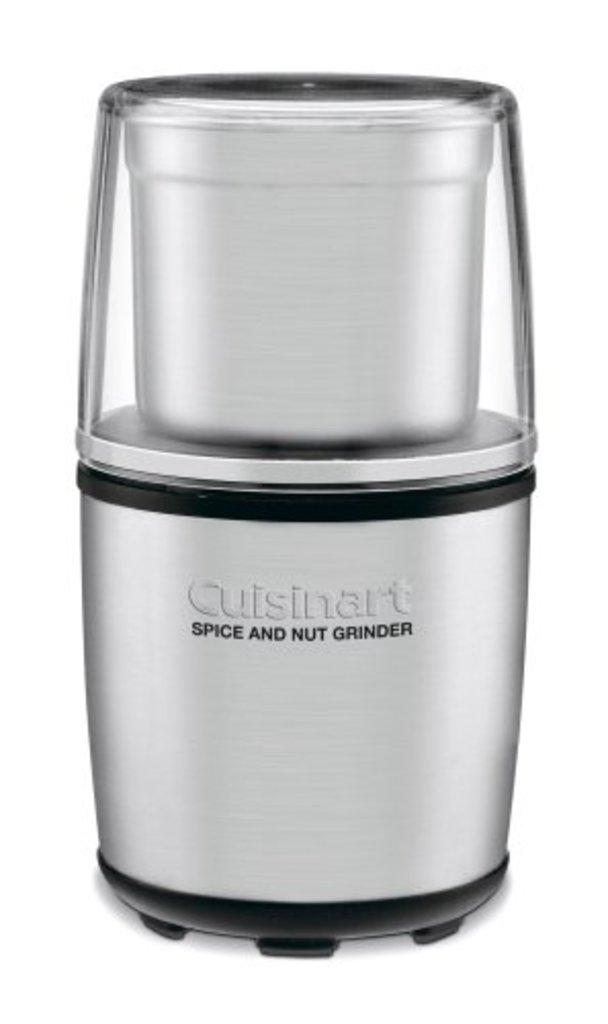<image>
Offer a succinct explanation of the picture presented. A picture of a Cuisinart Spice and Nut Grinder. 